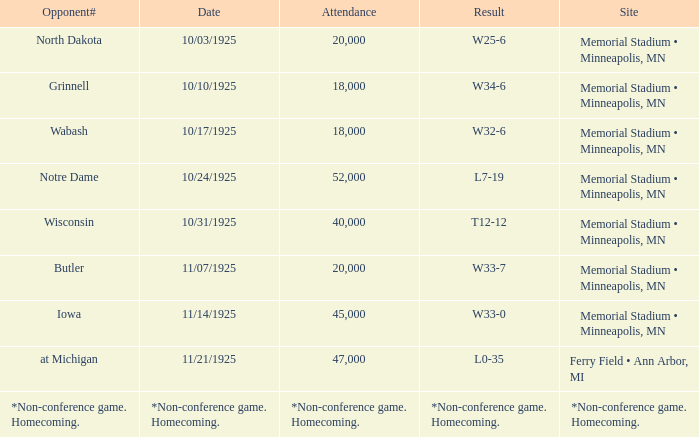In the event with 45,000 attendees, who was the opposing team? Iowa. 